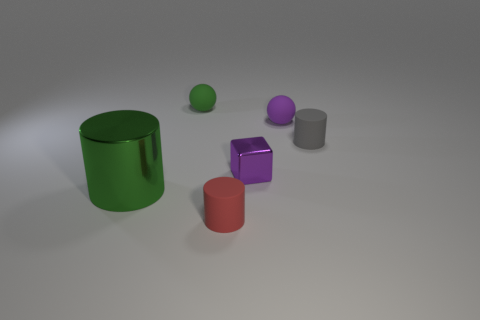There is a purple metallic object; does it have the same shape as the object that is in front of the large object? The purple metallic object in the image is a cube. However, it does not have the same shape as the object in front of the large green cylinder, which is a smaller red cylinder. 